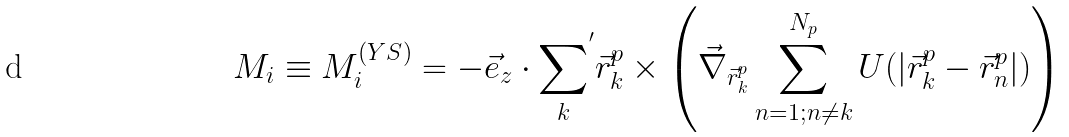Convert formula to latex. <formula><loc_0><loc_0><loc_500><loc_500>M _ { i } \equiv M _ { i } ^ { ( Y S ) } = - { \vec { e } } _ { z } \cdot { \sum _ { k } } ^ { ^ { \prime } } { \vec { r } } _ { k } ^ { p } \times \left ( { \vec { \nabla } } _ { { \vec { r } } _ { k } ^ { p } } \sum _ { n = 1 ; n \not = k } ^ { N _ { p } } U ( | { \vec { r } } _ { k } ^ { p } - { \vec { r } } _ { n } ^ { p } | ) \right )</formula> 